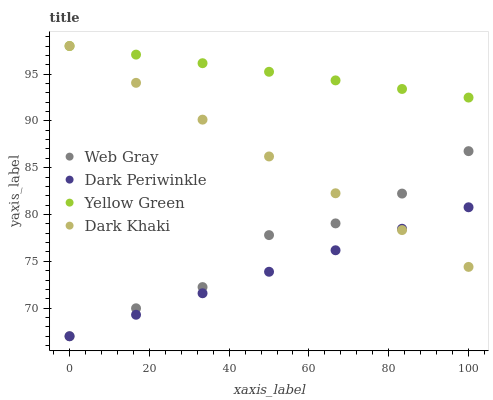Does Dark Periwinkle have the minimum area under the curve?
Answer yes or no. Yes. Does Yellow Green have the maximum area under the curve?
Answer yes or no. Yes. Does Web Gray have the minimum area under the curve?
Answer yes or no. No. Does Web Gray have the maximum area under the curve?
Answer yes or no. No. Is Yellow Green the smoothest?
Answer yes or no. Yes. Is Web Gray the roughest?
Answer yes or no. Yes. Is Dark Periwinkle the smoothest?
Answer yes or no. No. Is Dark Periwinkle the roughest?
Answer yes or no. No. Does Web Gray have the lowest value?
Answer yes or no. Yes. Does Yellow Green have the lowest value?
Answer yes or no. No. Does Yellow Green have the highest value?
Answer yes or no. Yes. Does Web Gray have the highest value?
Answer yes or no. No. Is Web Gray less than Yellow Green?
Answer yes or no. Yes. Is Yellow Green greater than Dark Periwinkle?
Answer yes or no. Yes. Does Yellow Green intersect Dark Khaki?
Answer yes or no. Yes. Is Yellow Green less than Dark Khaki?
Answer yes or no. No. Is Yellow Green greater than Dark Khaki?
Answer yes or no. No. Does Web Gray intersect Yellow Green?
Answer yes or no. No. 